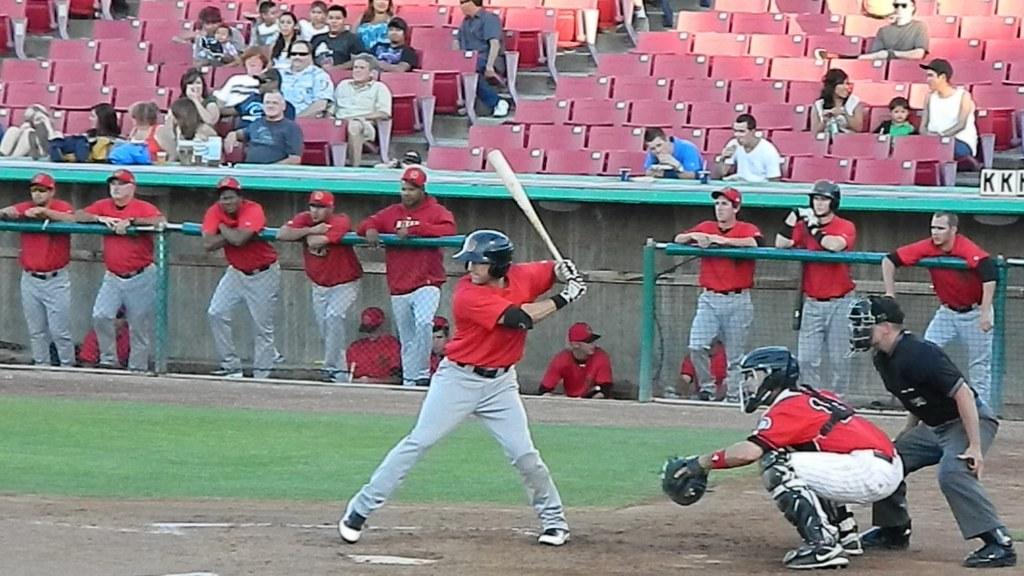What are those black letters on the right side near the stands?
Offer a terse response. Kk. 